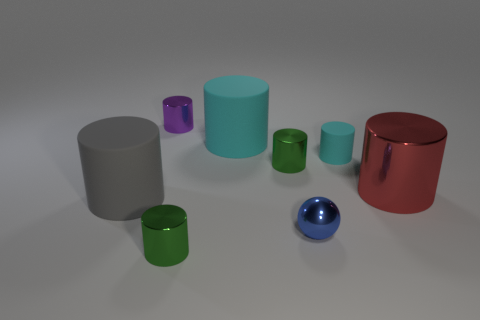How many other big cylinders have the same color as the big shiny cylinder?
Your answer should be very brief. 0. What size is the purple thing that is made of the same material as the small ball?
Keep it short and to the point. Small. How many things are either rubber objects right of the gray rubber cylinder or purple blocks?
Your answer should be compact. 2. Does the tiny thing that is to the right of the tiny blue shiny object have the same color as the shiny ball?
Provide a short and direct response. No. There is a purple thing that is the same shape as the tiny cyan rubber thing; what is its size?
Make the answer very short. Small. What is the color of the big rubber object that is to the left of the metallic thing that is to the left of the tiny green cylinder that is in front of the small blue metal ball?
Make the answer very short. Gray. Is the big red object made of the same material as the tiny blue sphere?
Provide a short and direct response. Yes. Are there any cyan rubber cylinders left of the big matte thing that is to the right of the small green shiny thing on the left side of the large cyan cylinder?
Give a very brief answer. No. Do the shiny sphere and the small matte object have the same color?
Provide a succinct answer. No. Are there fewer tiny blue metallic cubes than purple objects?
Keep it short and to the point. Yes. 